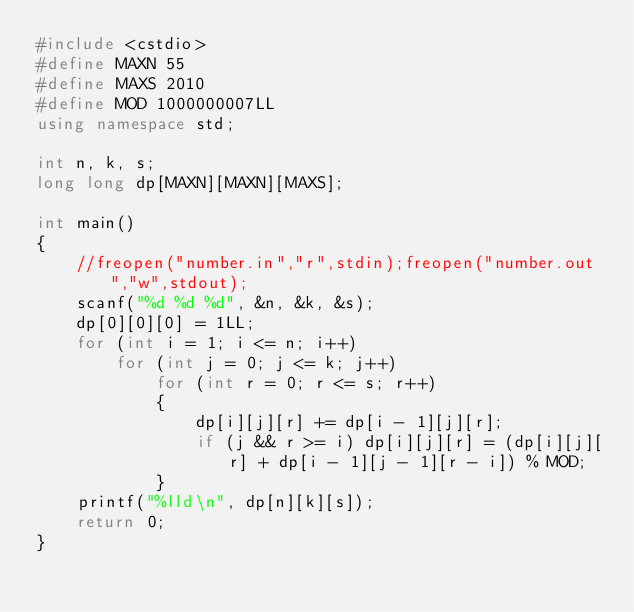Convert code to text. <code><loc_0><loc_0><loc_500><loc_500><_C++_>#include <cstdio>
#define MAXN 55
#define MAXS 2010
#define MOD 1000000007LL
using namespace std;

int n, k, s;
long long dp[MAXN][MAXN][MAXS];

int main()
{
	//freopen("number.in","r",stdin);freopen("number.out","w",stdout);
	scanf("%d %d %d", &n, &k, &s);
	dp[0][0][0] = 1LL;
	for (int i = 1; i <= n; i++)
		for (int j = 0; j <= k; j++)
			for (int r = 0; r <= s; r++)
			{
				dp[i][j][r] += dp[i - 1][j][r];
				if (j && r >= i) dp[i][j][r] = (dp[i][j][r] + dp[i - 1][j - 1][r - i]) % MOD;
			}
	printf("%lld\n", dp[n][k][s]);
	return 0;
}
</code> 